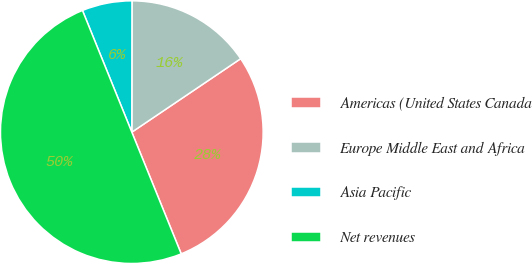Convert chart to OTSL. <chart><loc_0><loc_0><loc_500><loc_500><pie_chart><fcel>Americas (United States Canada<fcel>Europe Middle East and Africa<fcel>Asia Pacific<fcel>Net revenues<nl><fcel>28.31%<fcel>15.53%<fcel>6.15%<fcel>50.0%<nl></chart> 